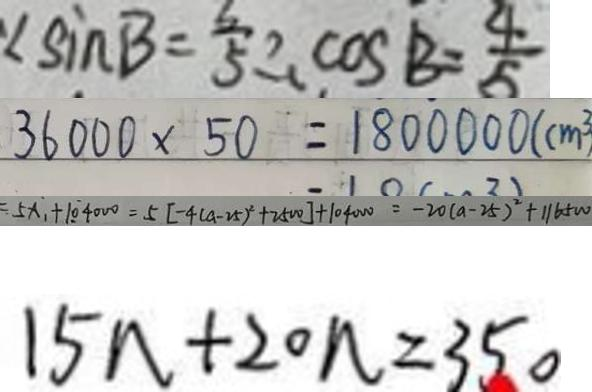Convert formula to latex. <formula><loc_0><loc_0><loc_500><loc_500>\angle \sin B = \frac { 3 } { 5 } \therefore \cos B = \frac { 4 } { 5 } 
 3 6 0 0 0 \times 5 0 = 1 8 0 0 0 0 0 ( c m ^ { 3 } ) 
 5 x _ { 1 } + 1 0 \dot { 4 } 0 0 0 = 5 [ - 4 ( a - 2 5 ) ^ { 2 } + 2 5 0 0 ] + 1 0 4 0 0 0 = - 2 0 ( a - 2 5 ) ^ { 2 } + 1 1 6 5 W 
 1 5 n + 2 0 n = 3 5 0</formula> 